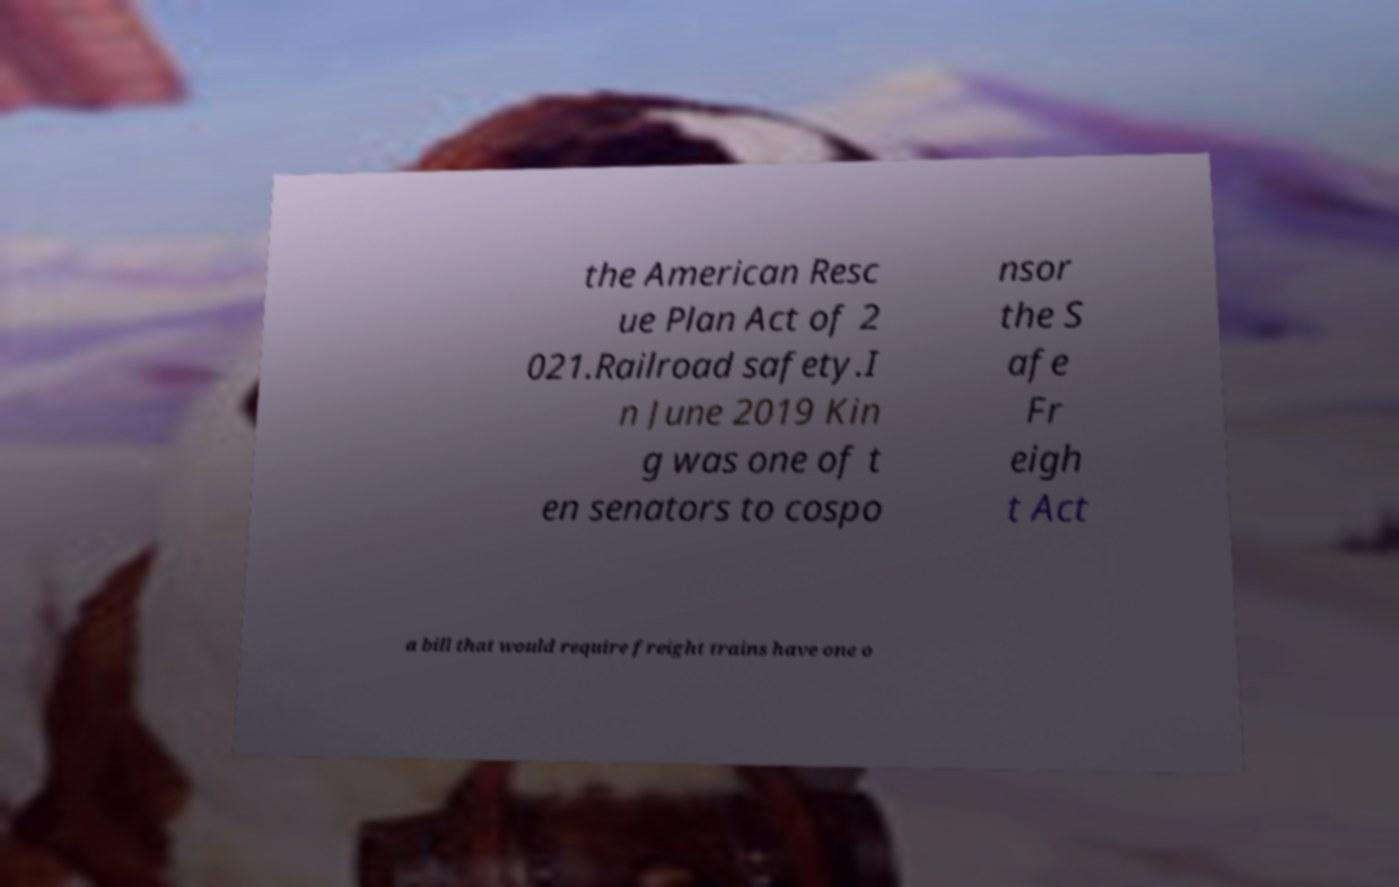Could you assist in decoding the text presented in this image and type it out clearly? the American Resc ue Plan Act of 2 021.Railroad safety.I n June 2019 Kin g was one of t en senators to cospo nsor the S afe Fr eigh t Act a bill that would require freight trains have one o 